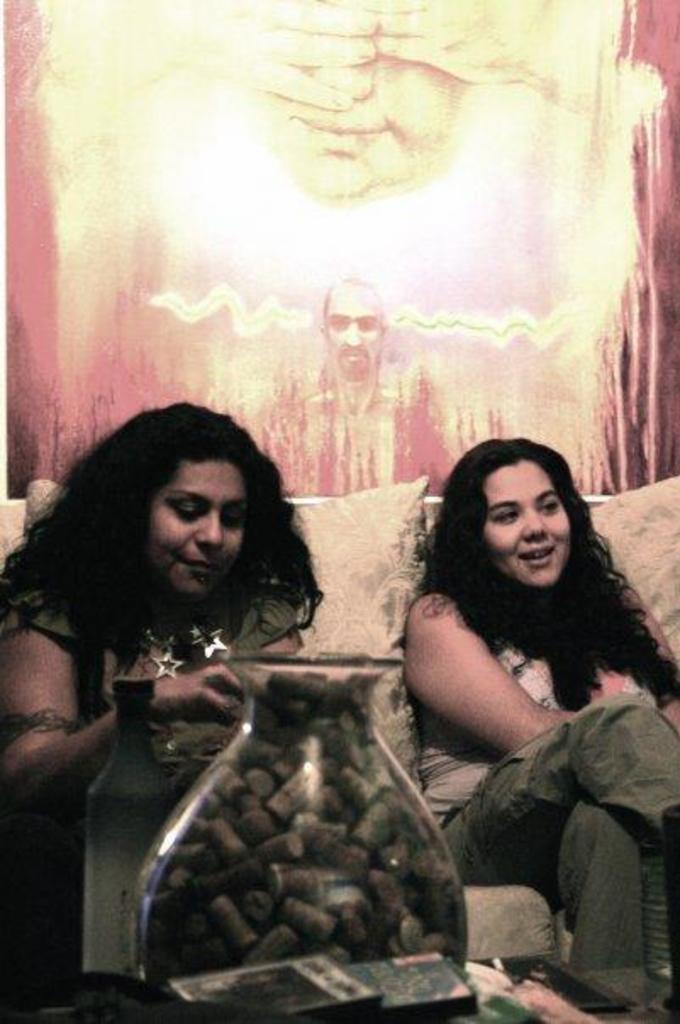In one or two sentences, can you explain what this image depicts? In this image I can see in the middle there is a glass jar. On the left side a woman is sitting on the sofa, on the right side there is another woman smiling, behind them there is the painting of a man. 